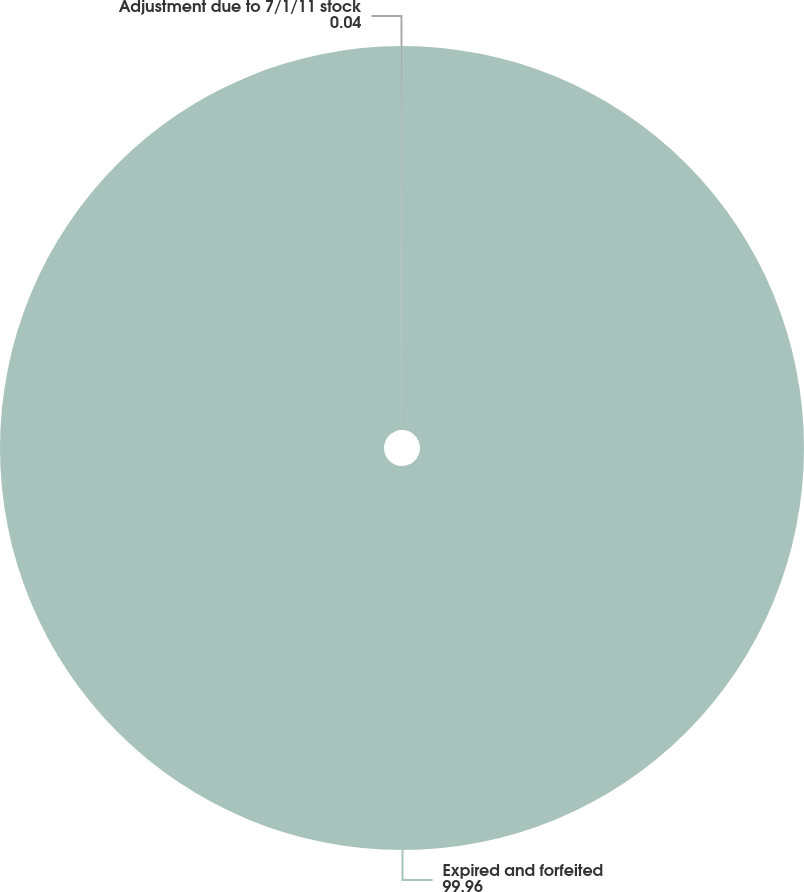Convert chart. <chart><loc_0><loc_0><loc_500><loc_500><pie_chart><fcel>Expired and forfeited<fcel>Adjustment due to 7/1/11 stock<nl><fcel>99.96%<fcel>0.04%<nl></chart> 